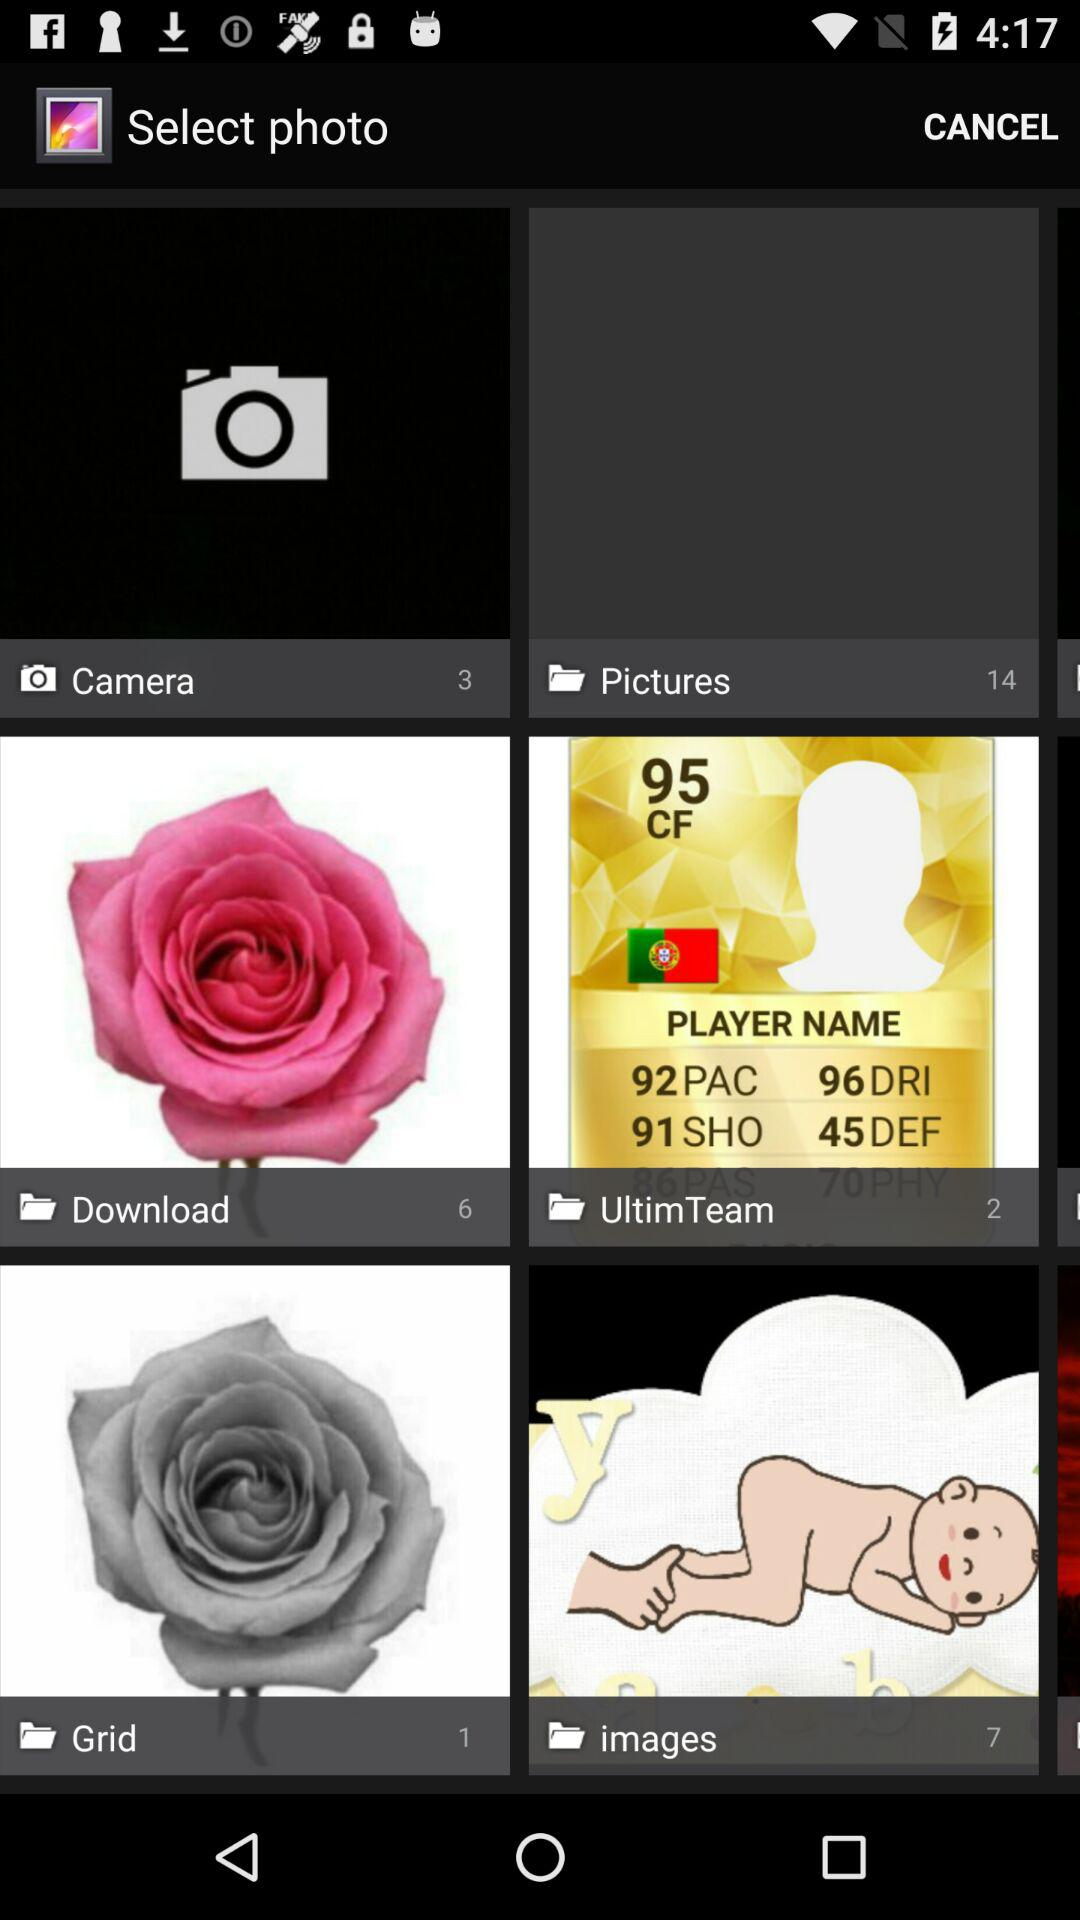What is the number of photos in the download folder? The number of photos in the download folder is 6. 